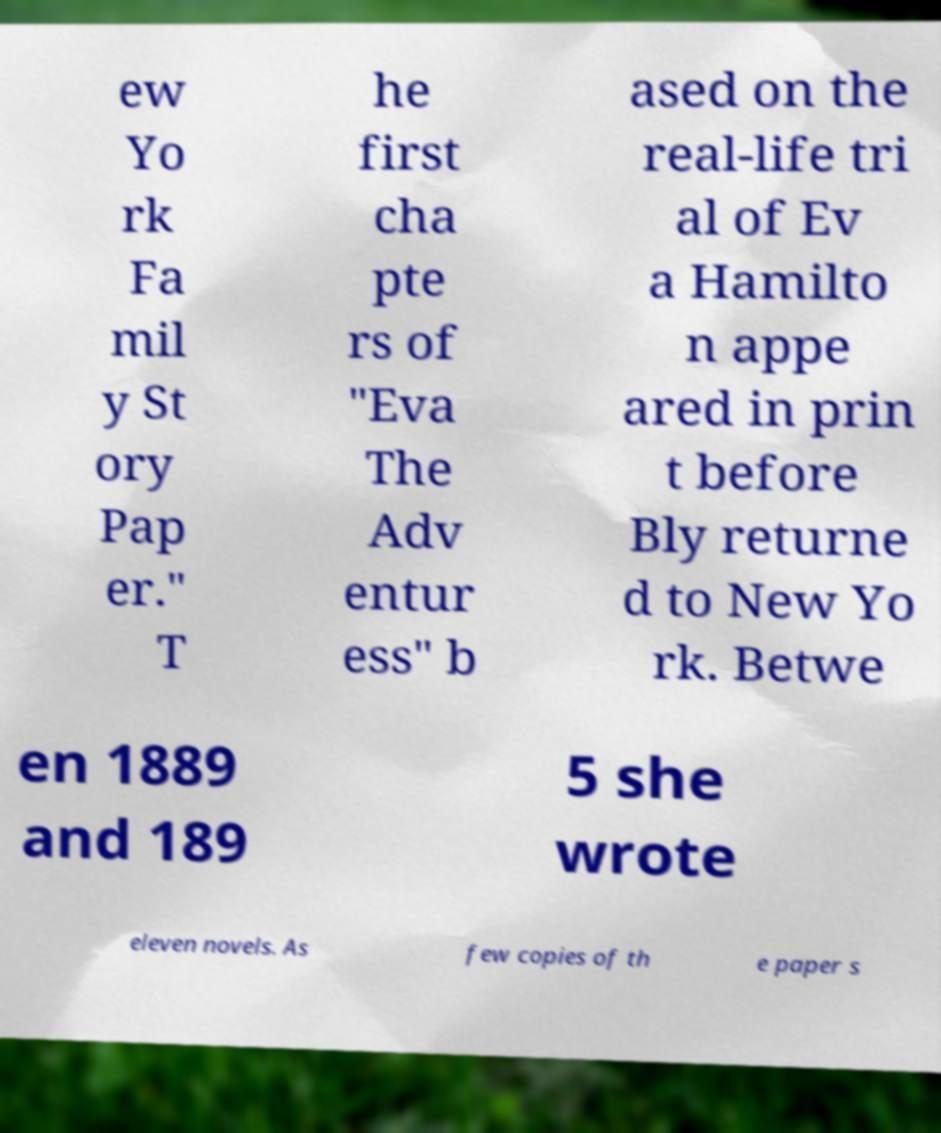Could you extract and type out the text from this image? ew Yo rk Fa mil y St ory Pap er." T he first cha pte rs of "Eva The Adv entur ess" b ased on the real-life tri al of Ev a Hamilto n appe ared in prin t before Bly returne d to New Yo rk. Betwe en 1889 and 189 5 she wrote eleven novels. As few copies of th e paper s 